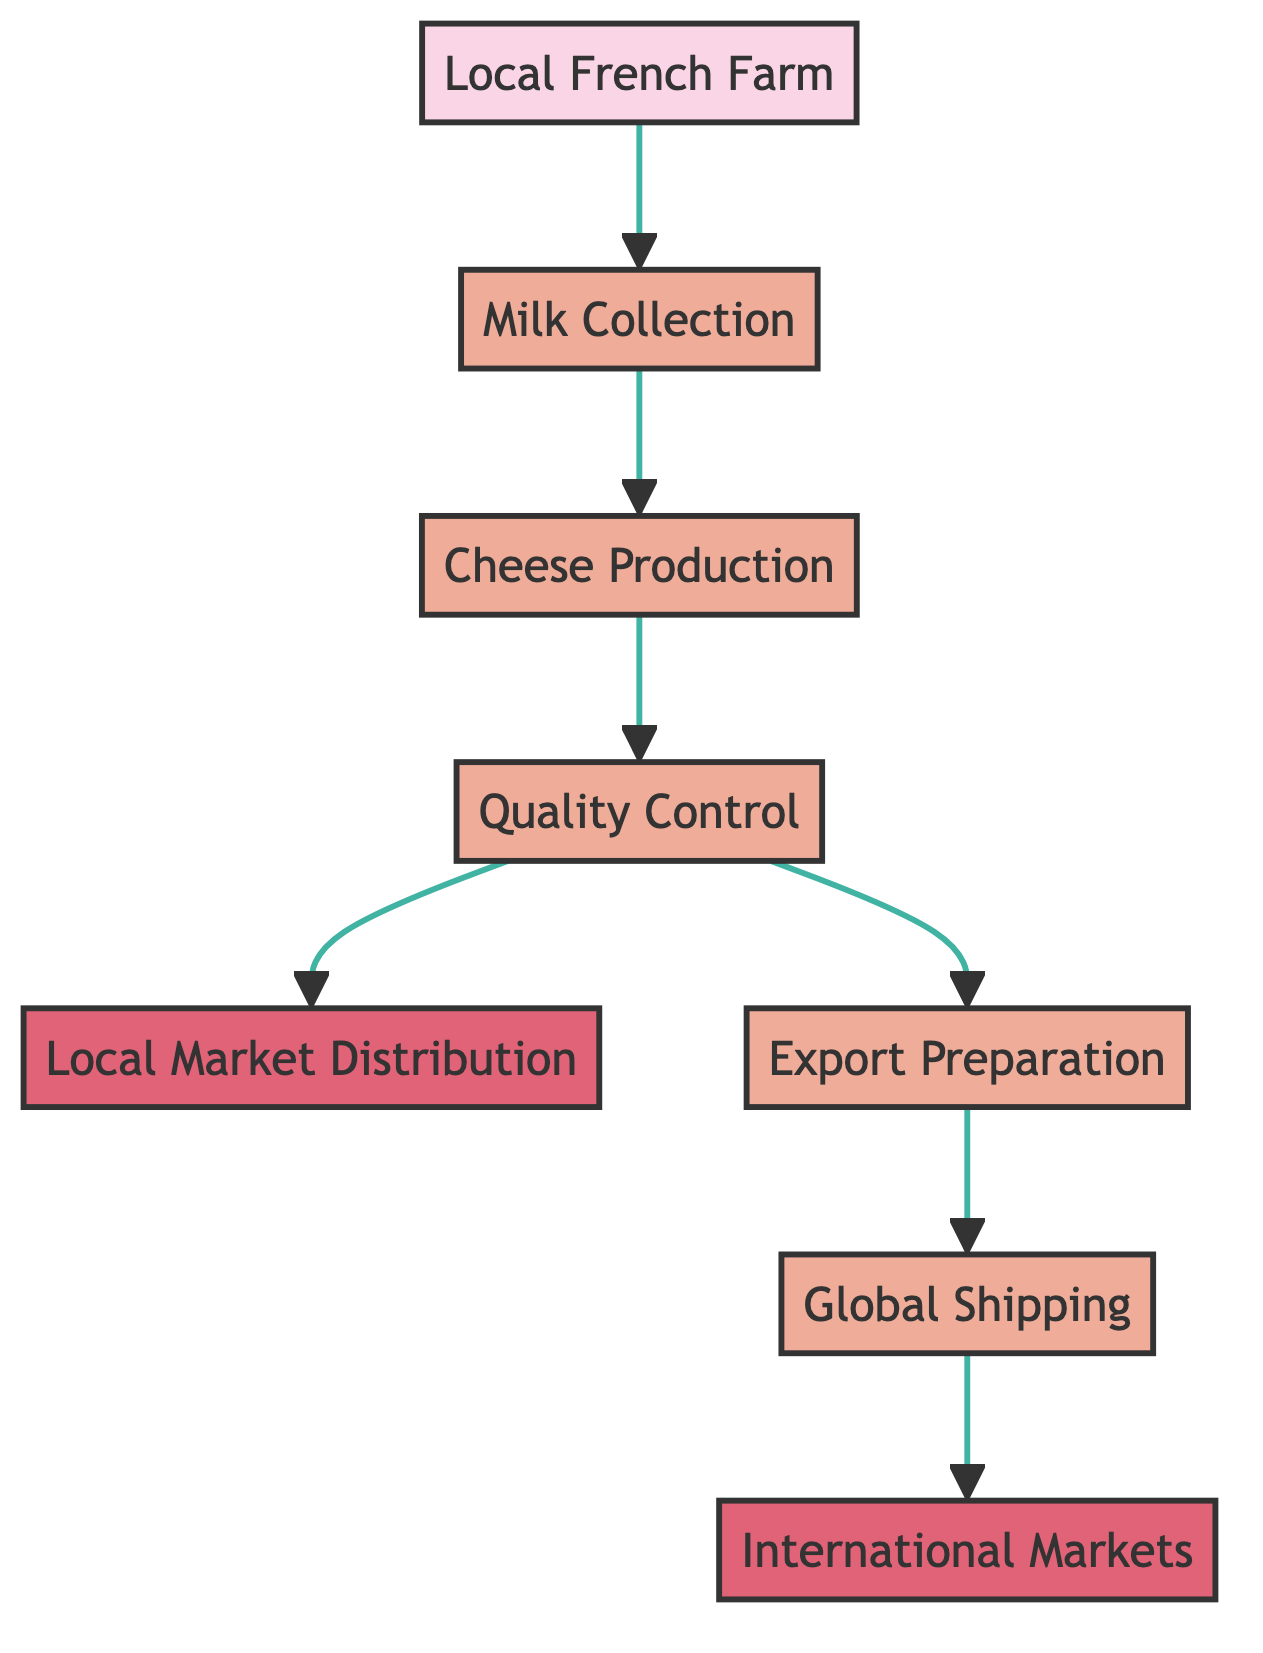What is the first step in the cheese journey? The first step is represented by the node "Local French Farm," which is where the cheese begins its journey.
Answer: Local French Farm How many process nodes are there in the diagram? The process nodes include "Milk Collection," "Cheese Production," "Quality Control," "Export Preparation," "Global Shipping," making a total of five process nodes.
Answer: 5 What is the output of the cheese journey directed to the local market? The output directed to the local markets is represented by the node "Local Market Distribution," which indicates where the cheese is sold in France.
Answer: Local Market Distribution Which node is directly connected to "Quality Control"? The "Quality Control" node has two direct connections: one to "Local Market Distribution" and another to "Export Preparation." Both are its subsequent steps.
Answer: Local Market Distribution and Export Preparation What is the last step in the international journey of cheese? The last step is represented by the node "International Markets," which shows the final destination for cheese after reaching global shipping.
Answer: International Markets What happens to the cheese after the quality check? After the quality check, cheese can either go to "Local Market Distribution" or "Export Preparation," indicating two potential paths for the cheese.
Answer: Local Market Distribution or Export Preparation Which node represents the preparation for markets outside of France? The node labeled "Export Preparation" signifies the step where cheese is packaged for international shipping, indicating the preparation for global markets.
Answer: Export Preparation How many output nodes are shown in the flowchart? There are two output nodes in the diagram: "Local Market Distribution" and "International Markets," indicating where the cheese ultimately ends up.
Answer: 2 What does the "Global Shipping" node indicate? The "Global Shipping" node indicates the process of transporting cheese to international markets using refrigerated containers, ensuring product integrity during transport.
Answer: Transporting cheese to international markets 